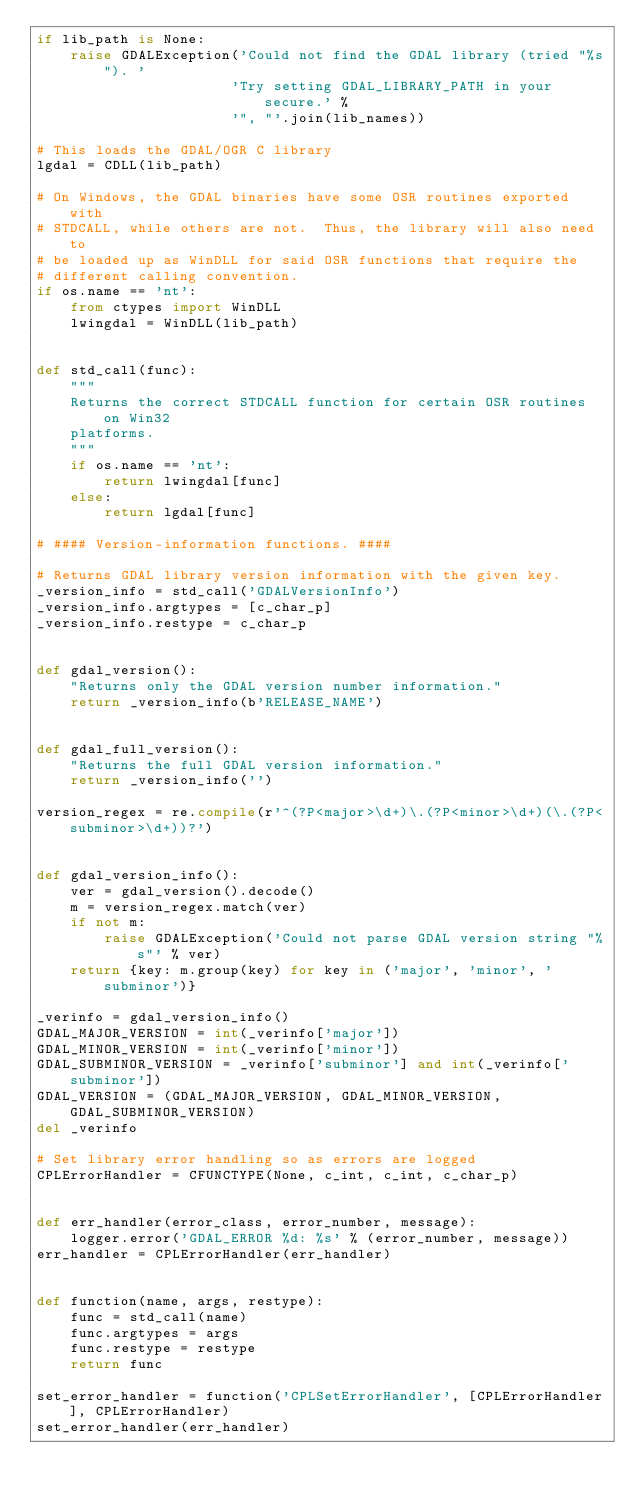Convert code to text. <code><loc_0><loc_0><loc_500><loc_500><_Python_>if lib_path is None:
    raise GDALException('Could not find the GDAL library (tried "%s"). '
                       'Try setting GDAL_LIBRARY_PATH in your secure.' %
                       '", "'.join(lib_names))

# This loads the GDAL/OGR C library
lgdal = CDLL(lib_path)

# On Windows, the GDAL binaries have some OSR routines exported with
# STDCALL, while others are not.  Thus, the library will also need to
# be loaded up as WinDLL for said OSR functions that require the
# different calling convention.
if os.name == 'nt':
    from ctypes import WinDLL
    lwingdal = WinDLL(lib_path)


def std_call(func):
    """
    Returns the correct STDCALL function for certain OSR routines on Win32
    platforms.
    """
    if os.name == 'nt':
        return lwingdal[func]
    else:
        return lgdal[func]

# #### Version-information functions. ####

# Returns GDAL library version information with the given key.
_version_info = std_call('GDALVersionInfo')
_version_info.argtypes = [c_char_p]
_version_info.restype = c_char_p


def gdal_version():
    "Returns only the GDAL version number information."
    return _version_info(b'RELEASE_NAME')


def gdal_full_version():
    "Returns the full GDAL version information."
    return _version_info('')

version_regex = re.compile(r'^(?P<major>\d+)\.(?P<minor>\d+)(\.(?P<subminor>\d+))?')


def gdal_version_info():
    ver = gdal_version().decode()
    m = version_regex.match(ver)
    if not m:
        raise GDALException('Could not parse GDAL version string "%s"' % ver)
    return {key: m.group(key) for key in ('major', 'minor', 'subminor')}

_verinfo = gdal_version_info()
GDAL_MAJOR_VERSION = int(_verinfo['major'])
GDAL_MINOR_VERSION = int(_verinfo['minor'])
GDAL_SUBMINOR_VERSION = _verinfo['subminor'] and int(_verinfo['subminor'])
GDAL_VERSION = (GDAL_MAJOR_VERSION, GDAL_MINOR_VERSION, GDAL_SUBMINOR_VERSION)
del _verinfo

# Set library error handling so as errors are logged
CPLErrorHandler = CFUNCTYPE(None, c_int, c_int, c_char_p)


def err_handler(error_class, error_number, message):
    logger.error('GDAL_ERROR %d: %s' % (error_number, message))
err_handler = CPLErrorHandler(err_handler)


def function(name, args, restype):
    func = std_call(name)
    func.argtypes = args
    func.restype = restype
    return func

set_error_handler = function('CPLSetErrorHandler', [CPLErrorHandler], CPLErrorHandler)
set_error_handler(err_handler)
</code> 